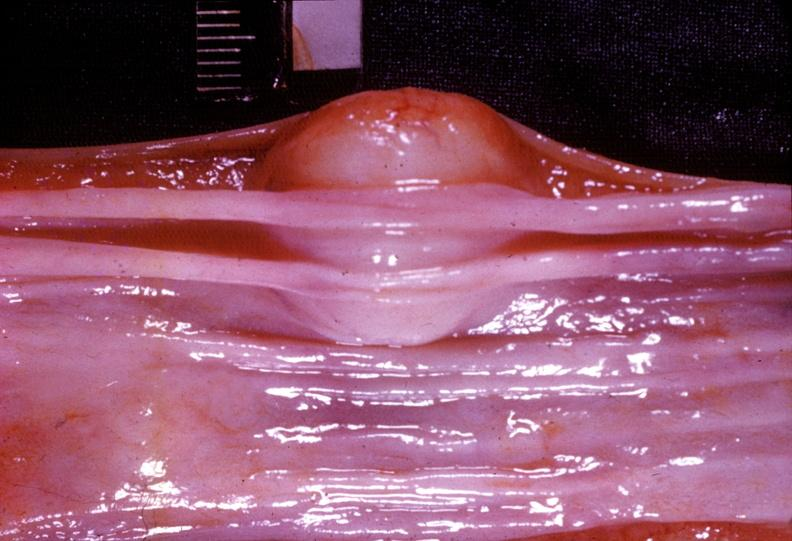where does this belong to?
Answer the question using a single word or phrase. Gastrointestinal system 